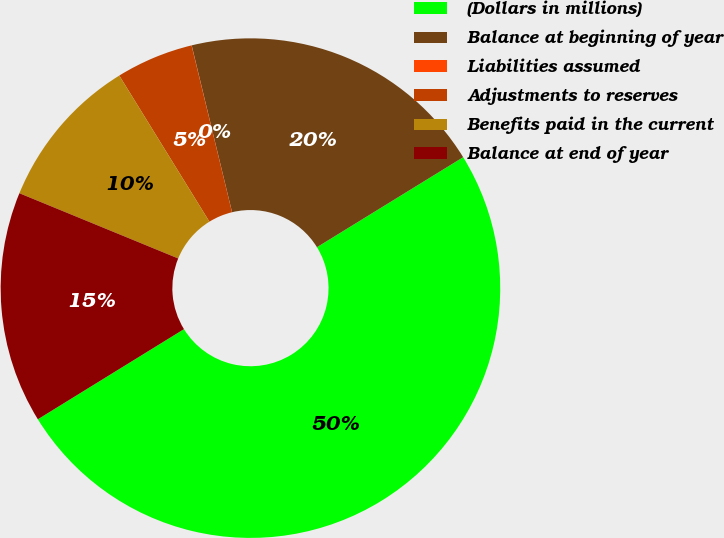<chart> <loc_0><loc_0><loc_500><loc_500><pie_chart><fcel>(Dollars in millions)<fcel>Balance at beginning of year<fcel>Liabilities assumed<fcel>Adjustments to reserves<fcel>Benefits paid in the current<fcel>Balance at end of year<nl><fcel>49.99%<fcel>20.0%<fcel>0.01%<fcel>5.01%<fcel>10.0%<fcel>15.0%<nl></chart> 